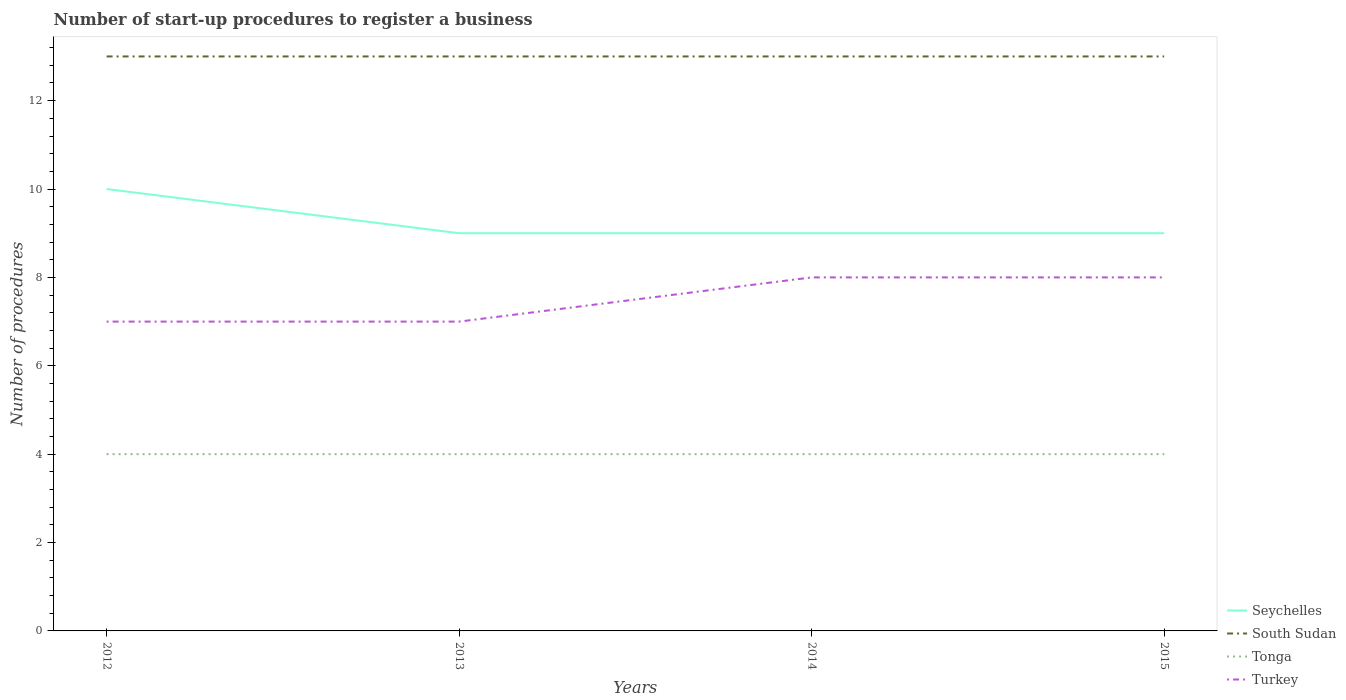How many different coloured lines are there?
Give a very brief answer. 4. Does the line corresponding to Turkey intersect with the line corresponding to South Sudan?
Your answer should be compact. No. In which year was the number of procedures required to register a business in Turkey maximum?
Your answer should be compact. 2012. What is the total number of procedures required to register a business in Seychelles in the graph?
Offer a terse response. 1. What is the difference between the highest and the second highest number of procedures required to register a business in Seychelles?
Provide a short and direct response. 1. What is the difference between the highest and the lowest number of procedures required to register a business in Turkey?
Ensure brevity in your answer.  2. How many lines are there?
Your answer should be very brief. 4. How many years are there in the graph?
Give a very brief answer. 4. Are the values on the major ticks of Y-axis written in scientific E-notation?
Provide a succinct answer. No. How are the legend labels stacked?
Give a very brief answer. Vertical. What is the title of the graph?
Provide a short and direct response. Number of start-up procedures to register a business. Does "Armenia" appear as one of the legend labels in the graph?
Your answer should be compact. No. What is the label or title of the Y-axis?
Ensure brevity in your answer.  Number of procedures. What is the Number of procedures in Seychelles in 2012?
Your answer should be very brief. 10. What is the Number of procedures of South Sudan in 2012?
Your answer should be very brief. 13. What is the Number of procedures of Tonga in 2012?
Give a very brief answer. 4. What is the Number of procedures of Seychelles in 2013?
Your answer should be compact. 9. What is the Number of procedures in Turkey in 2013?
Give a very brief answer. 7. What is the Number of procedures of Seychelles in 2014?
Your answer should be very brief. 9. What is the Number of procedures in Tonga in 2014?
Give a very brief answer. 4. What is the Number of procedures of Tonga in 2015?
Keep it short and to the point. 4. Across all years, what is the maximum Number of procedures in Turkey?
Your answer should be very brief. 8. Across all years, what is the minimum Number of procedures in Seychelles?
Offer a very short reply. 9. Across all years, what is the minimum Number of procedures in South Sudan?
Provide a succinct answer. 13. Across all years, what is the minimum Number of procedures in Tonga?
Your response must be concise. 4. What is the total Number of procedures of Seychelles in the graph?
Offer a very short reply. 37. What is the total Number of procedures of South Sudan in the graph?
Your answer should be very brief. 52. What is the total Number of procedures of Tonga in the graph?
Offer a very short reply. 16. What is the total Number of procedures of Turkey in the graph?
Give a very brief answer. 30. What is the difference between the Number of procedures of Turkey in 2012 and that in 2013?
Offer a very short reply. 0. What is the difference between the Number of procedures of Seychelles in 2012 and that in 2014?
Your answer should be very brief. 1. What is the difference between the Number of procedures in Tonga in 2012 and that in 2014?
Offer a very short reply. 0. What is the difference between the Number of procedures in Seychelles in 2012 and that in 2015?
Your answer should be very brief. 1. What is the difference between the Number of procedures in South Sudan in 2012 and that in 2015?
Give a very brief answer. 0. What is the difference between the Number of procedures in Seychelles in 2013 and that in 2014?
Offer a terse response. 0. What is the difference between the Number of procedures of South Sudan in 2013 and that in 2014?
Give a very brief answer. 0. What is the difference between the Number of procedures in Seychelles in 2013 and that in 2015?
Ensure brevity in your answer.  0. What is the difference between the Number of procedures of Tonga in 2013 and that in 2015?
Give a very brief answer. 0. What is the difference between the Number of procedures of Seychelles in 2014 and that in 2015?
Provide a short and direct response. 0. What is the difference between the Number of procedures in Turkey in 2014 and that in 2015?
Your answer should be very brief. 0. What is the difference between the Number of procedures of Seychelles in 2012 and the Number of procedures of Turkey in 2013?
Provide a short and direct response. 3. What is the difference between the Number of procedures in South Sudan in 2012 and the Number of procedures in Turkey in 2013?
Offer a very short reply. 6. What is the difference between the Number of procedures in Seychelles in 2012 and the Number of procedures in Turkey in 2014?
Offer a terse response. 2. What is the difference between the Number of procedures of South Sudan in 2012 and the Number of procedures of Tonga in 2014?
Your answer should be very brief. 9. What is the difference between the Number of procedures of South Sudan in 2012 and the Number of procedures of Turkey in 2014?
Make the answer very short. 5. What is the difference between the Number of procedures in Seychelles in 2012 and the Number of procedures in South Sudan in 2015?
Offer a very short reply. -3. What is the difference between the Number of procedures of South Sudan in 2012 and the Number of procedures of Turkey in 2015?
Your answer should be very brief. 5. What is the difference between the Number of procedures of South Sudan in 2013 and the Number of procedures of Tonga in 2014?
Give a very brief answer. 9. What is the difference between the Number of procedures in Seychelles in 2013 and the Number of procedures in South Sudan in 2015?
Provide a succinct answer. -4. What is the difference between the Number of procedures in South Sudan in 2013 and the Number of procedures in Tonga in 2015?
Your answer should be compact. 9. What is the difference between the Number of procedures in Tonga in 2013 and the Number of procedures in Turkey in 2015?
Your answer should be compact. -4. What is the difference between the Number of procedures of Seychelles in 2014 and the Number of procedures of South Sudan in 2015?
Provide a short and direct response. -4. What is the difference between the Number of procedures in Tonga in 2014 and the Number of procedures in Turkey in 2015?
Make the answer very short. -4. What is the average Number of procedures in Seychelles per year?
Offer a very short reply. 9.25. What is the average Number of procedures in Tonga per year?
Ensure brevity in your answer.  4. In the year 2012, what is the difference between the Number of procedures in Seychelles and Number of procedures in South Sudan?
Give a very brief answer. -3. In the year 2012, what is the difference between the Number of procedures in Seychelles and Number of procedures in Tonga?
Your answer should be compact. 6. In the year 2012, what is the difference between the Number of procedures in South Sudan and Number of procedures in Turkey?
Ensure brevity in your answer.  6. In the year 2013, what is the difference between the Number of procedures of Seychelles and Number of procedures of South Sudan?
Your answer should be compact. -4. In the year 2013, what is the difference between the Number of procedures in Seychelles and Number of procedures in Tonga?
Keep it short and to the point. 5. In the year 2013, what is the difference between the Number of procedures of South Sudan and Number of procedures of Tonga?
Your response must be concise. 9. In the year 2014, what is the difference between the Number of procedures in Seychelles and Number of procedures in Tonga?
Keep it short and to the point. 5. In the year 2014, what is the difference between the Number of procedures in South Sudan and Number of procedures in Turkey?
Provide a short and direct response. 5. In the year 2014, what is the difference between the Number of procedures in Tonga and Number of procedures in Turkey?
Offer a terse response. -4. In the year 2015, what is the difference between the Number of procedures in South Sudan and Number of procedures in Tonga?
Give a very brief answer. 9. In the year 2015, what is the difference between the Number of procedures of Tonga and Number of procedures of Turkey?
Provide a short and direct response. -4. What is the ratio of the Number of procedures of South Sudan in 2012 to that in 2013?
Give a very brief answer. 1. What is the ratio of the Number of procedures of Tonga in 2012 to that in 2013?
Offer a terse response. 1. What is the ratio of the Number of procedures of Turkey in 2012 to that in 2013?
Your answer should be very brief. 1. What is the ratio of the Number of procedures in Seychelles in 2012 to that in 2014?
Keep it short and to the point. 1.11. What is the ratio of the Number of procedures of South Sudan in 2012 to that in 2014?
Provide a succinct answer. 1. What is the ratio of the Number of procedures of Turkey in 2012 to that in 2014?
Give a very brief answer. 0.88. What is the ratio of the Number of procedures of Seychelles in 2012 to that in 2015?
Provide a short and direct response. 1.11. What is the ratio of the Number of procedures in South Sudan in 2012 to that in 2015?
Your answer should be very brief. 1. What is the ratio of the Number of procedures of Tonga in 2012 to that in 2015?
Offer a terse response. 1. What is the ratio of the Number of procedures in Turkey in 2012 to that in 2015?
Your answer should be compact. 0.88. What is the ratio of the Number of procedures of Turkey in 2013 to that in 2014?
Keep it short and to the point. 0.88. What is the ratio of the Number of procedures in Seychelles in 2013 to that in 2015?
Offer a terse response. 1. What is the ratio of the Number of procedures of South Sudan in 2013 to that in 2015?
Keep it short and to the point. 1. What is the ratio of the Number of procedures in Turkey in 2013 to that in 2015?
Your answer should be compact. 0.88. What is the ratio of the Number of procedures of Seychelles in 2014 to that in 2015?
Keep it short and to the point. 1. What is the ratio of the Number of procedures of South Sudan in 2014 to that in 2015?
Provide a succinct answer. 1. What is the ratio of the Number of procedures of Tonga in 2014 to that in 2015?
Make the answer very short. 1. What is the ratio of the Number of procedures in Turkey in 2014 to that in 2015?
Offer a terse response. 1. What is the difference between the highest and the second highest Number of procedures of South Sudan?
Provide a succinct answer. 0. What is the difference between the highest and the second highest Number of procedures of Tonga?
Offer a terse response. 0. What is the difference between the highest and the lowest Number of procedures in Seychelles?
Your answer should be compact. 1. What is the difference between the highest and the lowest Number of procedures in Tonga?
Give a very brief answer. 0. What is the difference between the highest and the lowest Number of procedures of Turkey?
Provide a succinct answer. 1. 